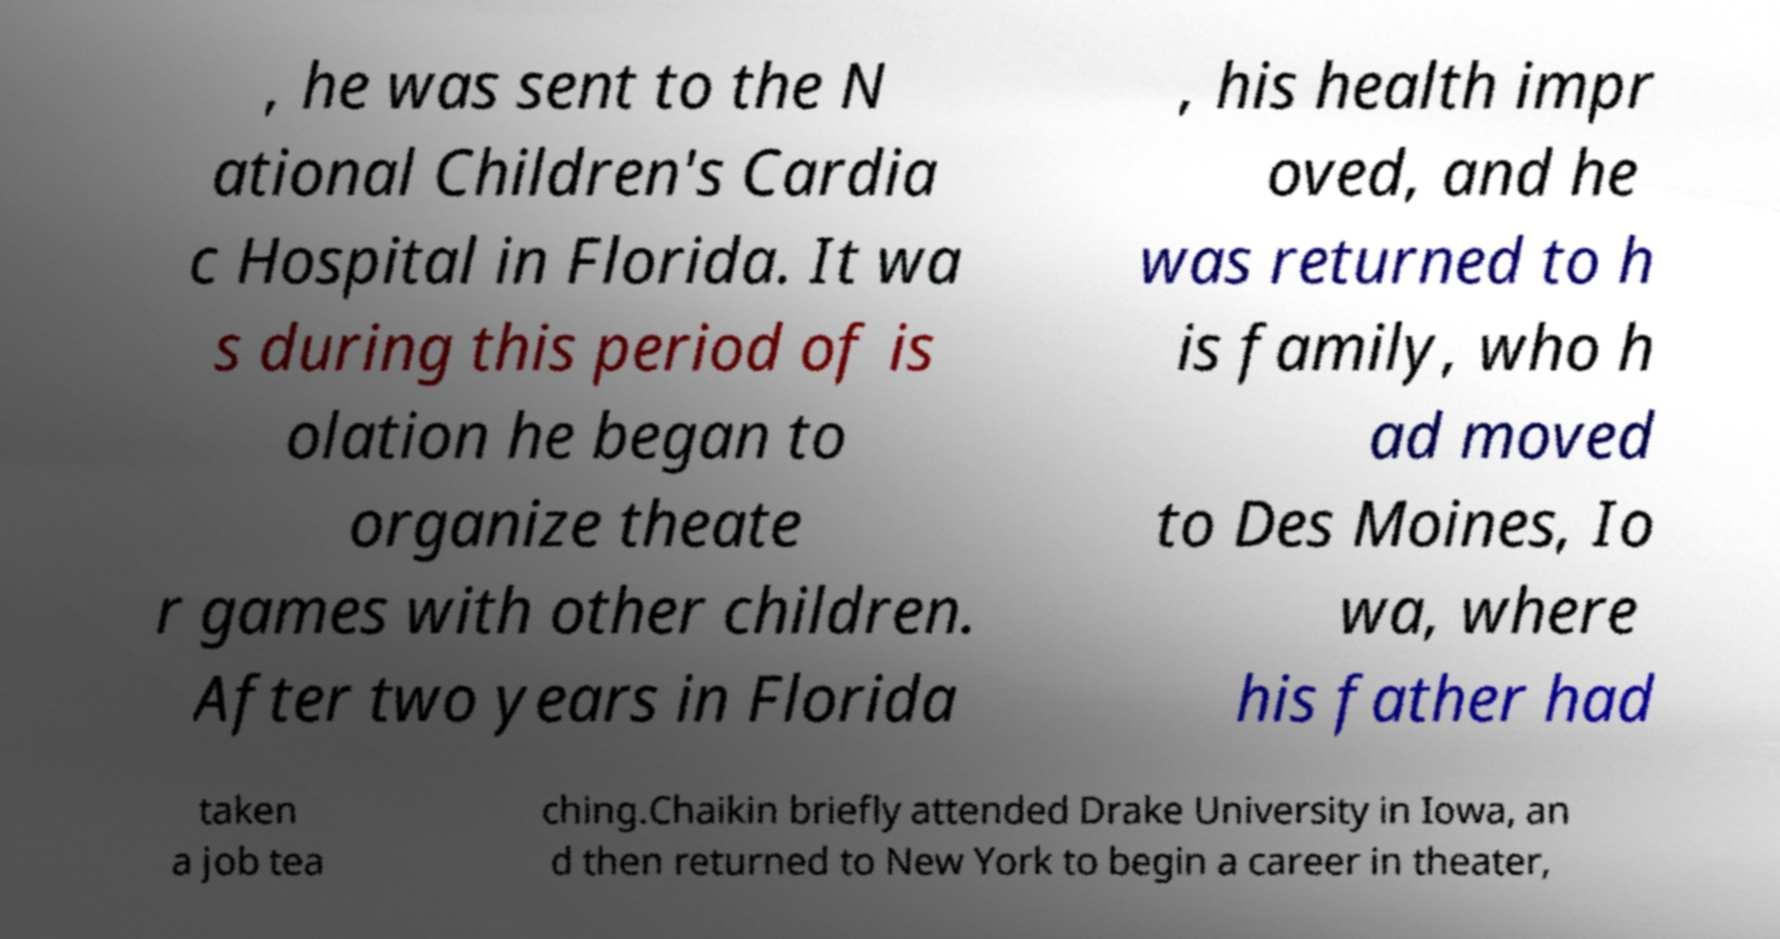Could you assist in decoding the text presented in this image and type it out clearly? , he was sent to the N ational Children's Cardia c Hospital in Florida. It wa s during this period of is olation he began to organize theate r games with other children. After two years in Florida , his health impr oved, and he was returned to h is family, who h ad moved to Des Moines, Io wa, where his father had taken a job tea ching.Chaikin briefly attended Drake University in Iowa, an d then returned to New York to begin a career in theater, 